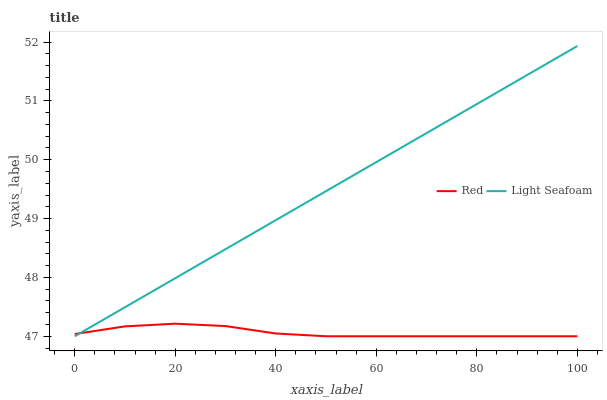Does Red have the minimum area under the curve?
Answer yes or no. Yes. Does Light Seafoam have the maximum area under the curve?
Answer yes or no. Yes. Does Red have the maximum area under the curve?
Answer yes or no. No. Is Light Seafoam the smoothest?
Answer yes or no. Yes. Is Red the roughest?
Answer yes or no. Yes. Is Red the smoothest?
Answer yes or no. No. Does Light Seafoam have the lowest value?
Answer yes or no. Yes. Does Light Seafoam have the highest value?
Answer yes or no. Yes. Does Red have the highest value?
Answer yes or no. No. Does Red intersect Light Seafoam?
Answer yes or no. Yes. Is Red less than Light Seafoam?
Answer yes or no. No. Is Red greater than Light Seafoam?
Answer yes or no. No. 